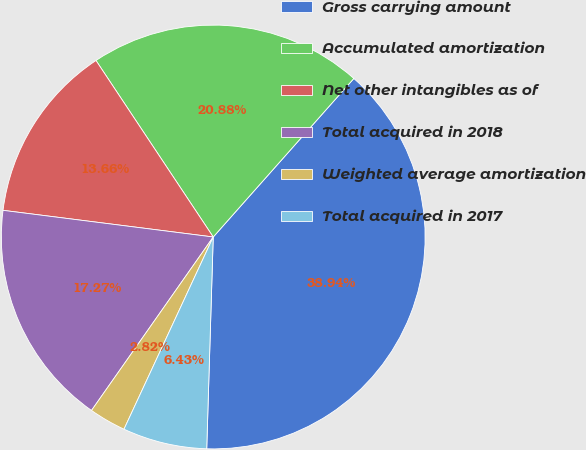Convert chart to OTSL. <chart><loc_0><loc_0><loc_500><loc_500><pie_chart><fcel>Gross carrying amount<fcel>Accumulated amortization<fcel>Net other intangibles as of<fcel>Total acquired in 2018<fcel>Weighted average amortization<fcel>Total acquired in 2017<nl><fcel>38.94%<fcel>20.88%<fcel>13.66%<fcel>17.27%<fcel>2.82%<fcel>6.43%<nl></chart> 